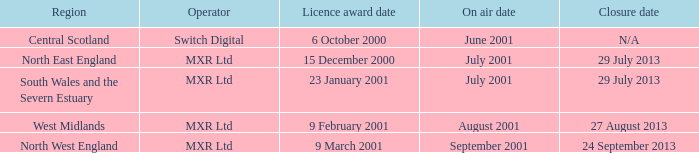What is the license award date for North East England? 15 December 2000. 